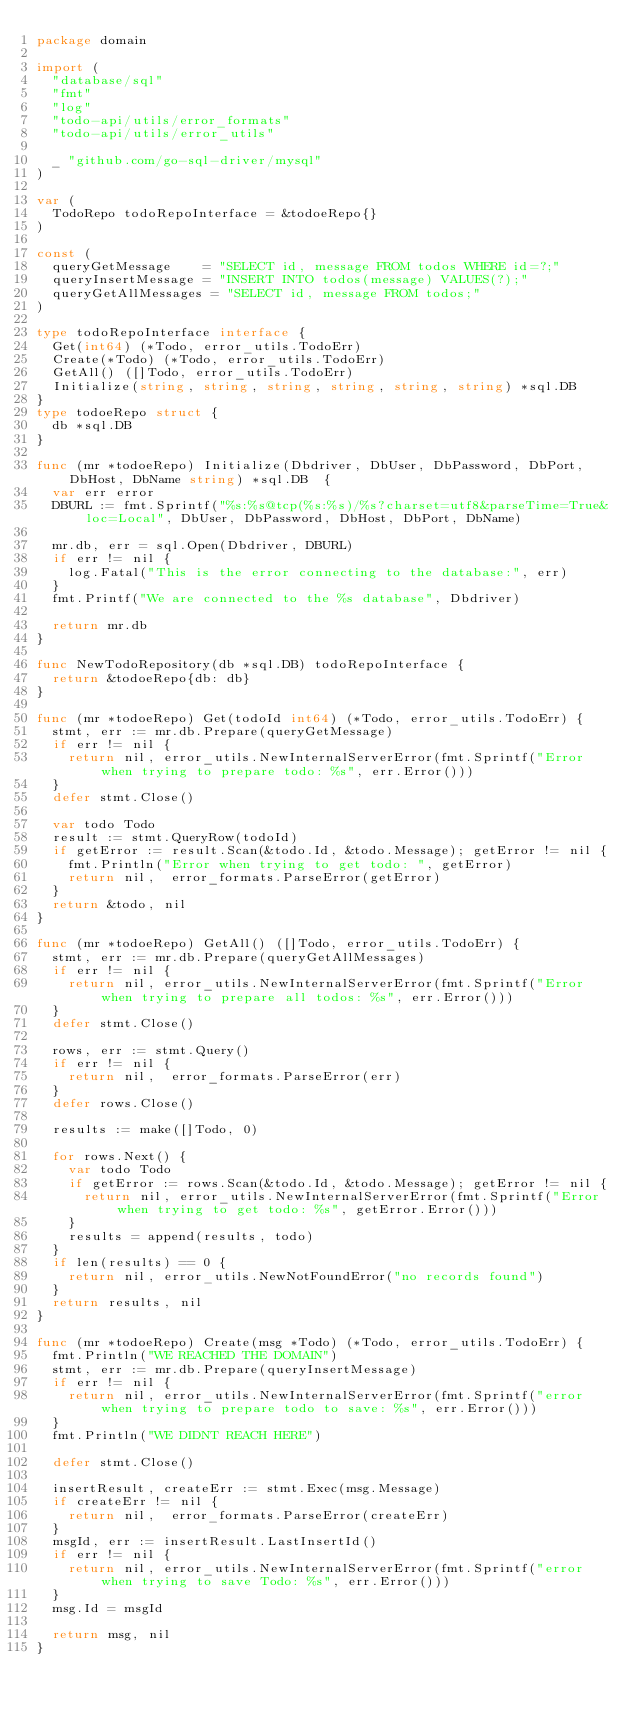Convert code to text. <code><loc_0><loc_0><loc_500><loc_500><_Go_>package domain

import (
	"database/sql"
	"fmt"
	"log"
	"todo-api/utils/error_formats"
	"todo-api/utils/error_utils"

	_ "github.com/go-sql-driver/mysql"
)

var (
	TodoRepo todoRepoInterface = &todoeRepo{}
)

const (
	queryGetMessage    = "SELECT id, message FROM todos WHERE id=?;"
	queryInsertMessage = "INSERT INTO todos(message) VALUES(?);"
	queryGetAllMessages = "SELECT id, message FROM todos;"
)

type todoRepoInterface interface {
	Get(int64) (*Todo, error_utils.TodoErr)
	Create(*Todo) (*Todo, error_utils.TodoErr)
	GetAll() ([]Todo, error_utils.TodoErr)
	Initialize(string, string, string, string, string, string) *sql.DB
}
type todoeRepo struct {
	db *sql.DB
}

func (mr *todoeRepo) Initialize(Dbdriver, DbUser, DbPassword, DbPort, DbHost, DbName string) *sql.DB  {
	var err error
	DBURL := fmt.Sprintf("%s:%s@tcp(%s:%s)/%s?charset=utf8&parseTime=True&loc=Local", DbUser, DbPassword, DbHost, DbPort, DbName)

	mr.db, err = sql.Open(Dbdriver, DBURL)
	if err != nil {
		log.Fatal("This is the error connecting to the database:", err)
	}
	fmt.Printf("We are connected to the %s database", Dbdriver)

	return mr.db
}

func NewTodoRepository(db *sql.DB) todoRepoInterface {
	return &todoeRepo{db: db}
}

func (mr *todoeRepo) Get(todoId int64) (*Todo, error_utils.TodoErr) {
	stmt, err := mr.db.Prepare(queryGetMessage)
	if err != nil {
		return nil, error_utils.NewInternalServerError(fmt.Sprintf("Error when trying to prepare todo: %s", err.Error()))
	}
	defer stmt.Close()

	var todo Todo
	result := stmt.QueryRow(todoId)
	if getError := result.Scan(&todo.Id, &todo.Message); getError != nil {
		fmt.Println("Error when trying to get todo: ", getError)
		return nil,  error_formats.ParseError(getError)
	}
	return &todo, nil
}

func (mr *todoeRepo) GetAll() ([]Todo, error_utils.TodoErr) {
	stmt, err := mr.db.Prepare(queryGetAllMessages)
	if err != nil {
		return nil, error_utils.NewInternalServerError(fmt.Sprintf("Error when trying to prepare all todos: %s", err.Error()))
	}
	defer stmt.Close()

	rows, err := stmt.Query()
	if err != nil {
		return nil,  error_formats.ParseError(err)
	}
	defer rows.Close()

	results := make([]Todo, 0)

	for rows.Next() {
		var todo Todo
		if getError := rows.Scan(&todo.Id, &todo.Message); getError != nil {
			return nil, error_utils.NewInternalServerError(fmt.Sprintf("Error when trying to get todo: %s", getError.Error()))
		}
		results = append(results, todo)
	}
	if len(results) == 0 {
		return nil, error_utils.NewNotFoundError("no records found")
	}
	return results, nil
}

func (mr *todoeRepo) Create(msg *Todo) (*Todo, error_utils.TodoErr) {
	fmt.Println("WE REACHED THE DOMAIN")
	stmt, err := mr.db.Prepare(queryInsertMessage)
	if err != nil {
		return nil, error_utils.NewInternalServerError(fmt.Sprintf("error when trying to prepare todo to save: %s", err.Error()))
	}
	fmt.Println("WE DIDNT REACH HERE")

	defer stmt.Close()

	insertResult, createErr := stmt.Exec(msg.Message)
	if createErr != nil {
		return nil,  error_formats.ParseError(createErr)
	}
	msgId, err := insertResult.LastInsertId()
	if err != nil {
		return nil, error_utils.NewInternalServerError(fmt.Sprintf("error when trying to save Todo: %s", err.Error()))
	}
	msg.Id = msgId

	return msg, nil
}</code> 